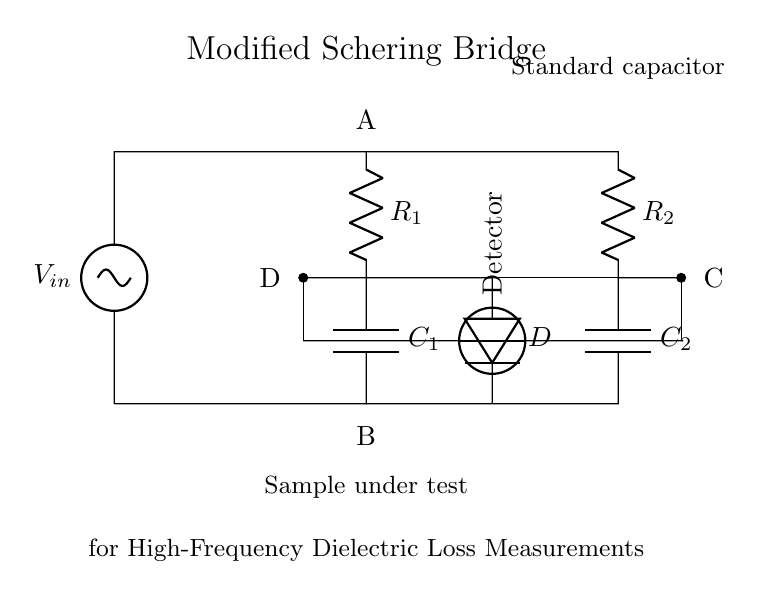What is the type of bridge depicted in the diagram? The circuit is identified as a Modified Schering Bridge, as labeled in the diagram. It specifically mentions its application for high-frequency dielectric loss measurements.
Answer: Modified Schering Bridge What components are present in the circuit? The circuit consists of two resistors (R1 and R2), two capacitors (C1 and C2), a diode (D), a sample under test, a standard capacitor, and a detector. This identification is based on the labels provided in the circuit.
Answer: Resistors, capacitors, diode, sample, detector What is the purpose of the detector in this circuit? The detector is used to measure the resultant voltage across the bridge, which helps in determining the dielectric loss of the sample under test. It is a critical component for quantifying the performance of the bridge.
Answer: Measure dielectric loss How many capacitors are present in the circuit, and what are they? There are two capacitors present in the circuit: C1 and C2. They are indicated as crucial components for the bridge measurement, where each capacitor contributes to the overall impedance used for the calculations.
Answer: C1, C2 Which nodes are connected to the voltage source? The voltage source is connected to nodes A and B of the bridge. A is the positive terminal while B is the negative terminal, which is standard for voltage supplies in such circuits to ensure correct polarity for measurements.
Answer: A, B What does the label 'D' represent in the circuit? The label 'D' represents a diode that helps control current flow and provides protection within the circuit. Its positioning and designation within the bridge indicate its function in ensuring signal integrity for accurate measurements.
Answer: Diode How does changing the capacitor values affect the bridge balance? Changing the capacitor values alters the reactance and impedance ratios in the bridge, which can lead to an imbalance or balance depending on their values. The bridge is designed to be balanced when specific conditions between R1, R2, C1, and C2 are met, affecting the output voltage readings.
Answer: Affects balance 